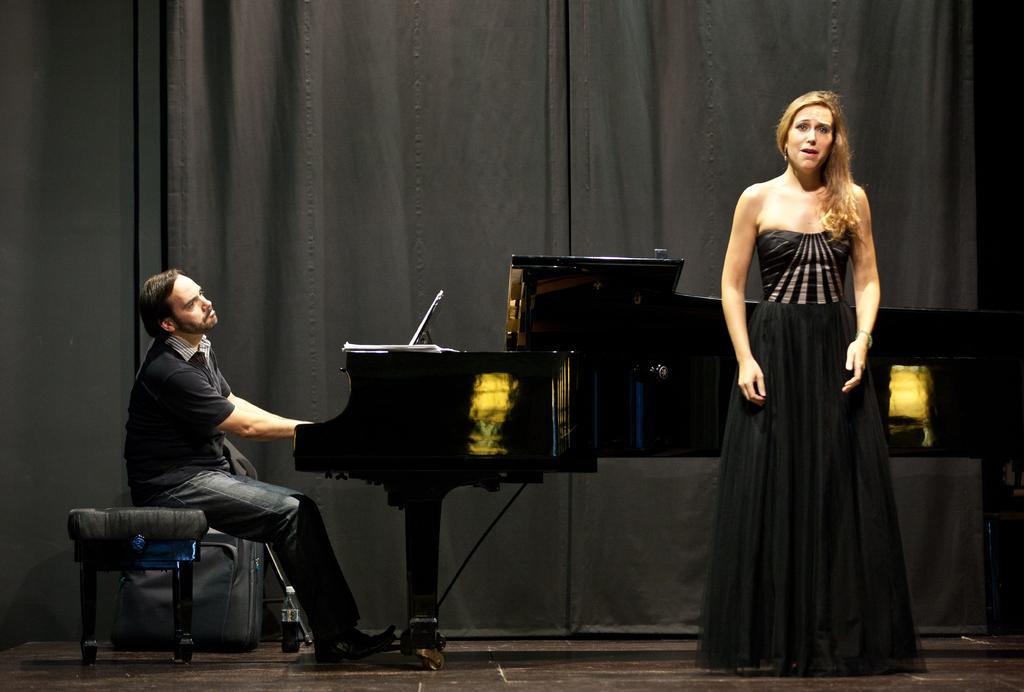Describe this image in one or two sentences. In this Image I see a man who is sitting on the stool and he is playing a keyboard and I see a woman who is standing over here. In the background I see the black curtain. 